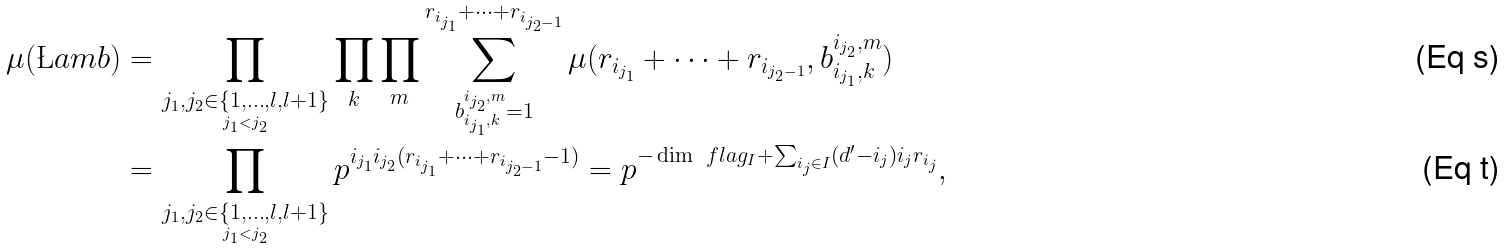<formula> <loc_0><loc_0><loc_500><loc_500>\mu ( \L a m b ) & = \prod _ { \underset { j _ { 1 } < j _ { 2 } } { j _ { 1 } , j _ { 2 } \in \{ 1 , \dots , l , l + 1 \} } } \prod _ { k } \prod _ { m } \sum _ { b _ { i _ { j _ { 1 } } , k } ^ { i _ { j _ { 2 } } , m } = 1 } ^ { r _ { i _ { j _ { 1 } } } + \dots + r _ { i _ { j _ { 2 } - 1 } } } \mu ( r _ { i _ { j _ { 1 } } } + \dots + r _ { i _ { j _ { 2 } - 1 } } , b _ { i _ { j _ { 1 } } , k } ^ { i _ { j _ { 2 } } , m } ) \\ & = \prod _ { \underset { j _ { 1 } < j _ { 2 } } { j _ { 1 } , j _ { 2 } \in \{ 1 , \dots , l , l + 1 \} } } p ^ { i _ { j _ { 1 } } i _ { j _ { 2 } } ( r _ { i _ { j _ { 1 } } } + \dots + r _ { i _ { j _ { 2 } - 1 } } - 1 ) } = p ^ { - \dim \ f l a g _ { I } + \sum _ { i _ { j } \in I } ( d ^ { \prime } - i _ { j } ) i _ { j } r _ { i _ { j } } } ,</formula> 